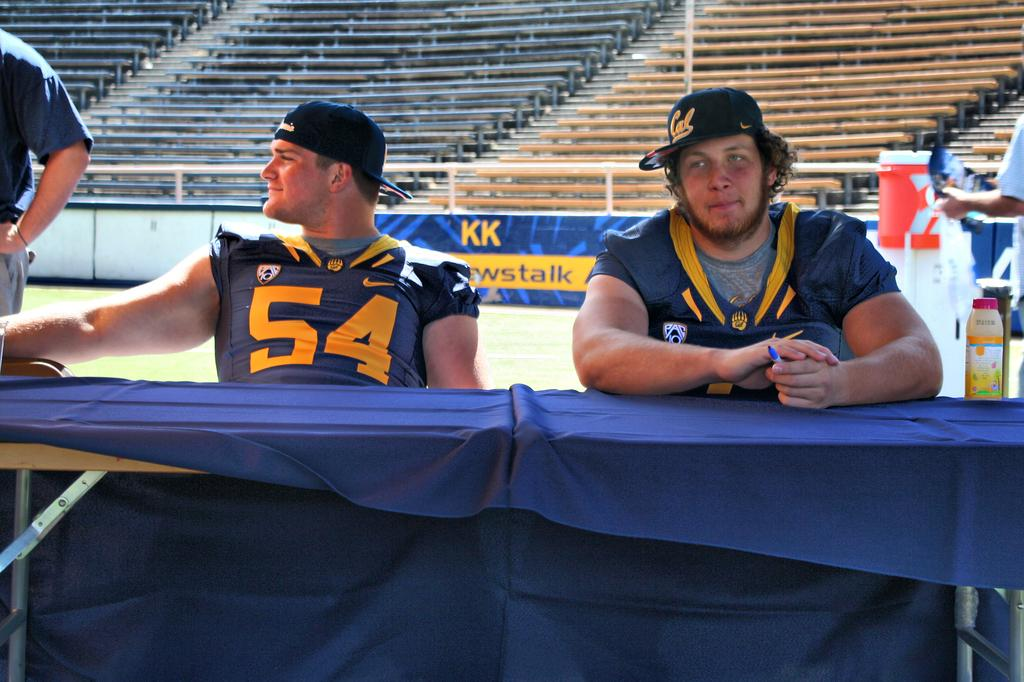<image>
Relay a brief, clear account of the picture shown. Two athletes sit at a table, one in a Cal cap and the other in a number 54 uniform. 